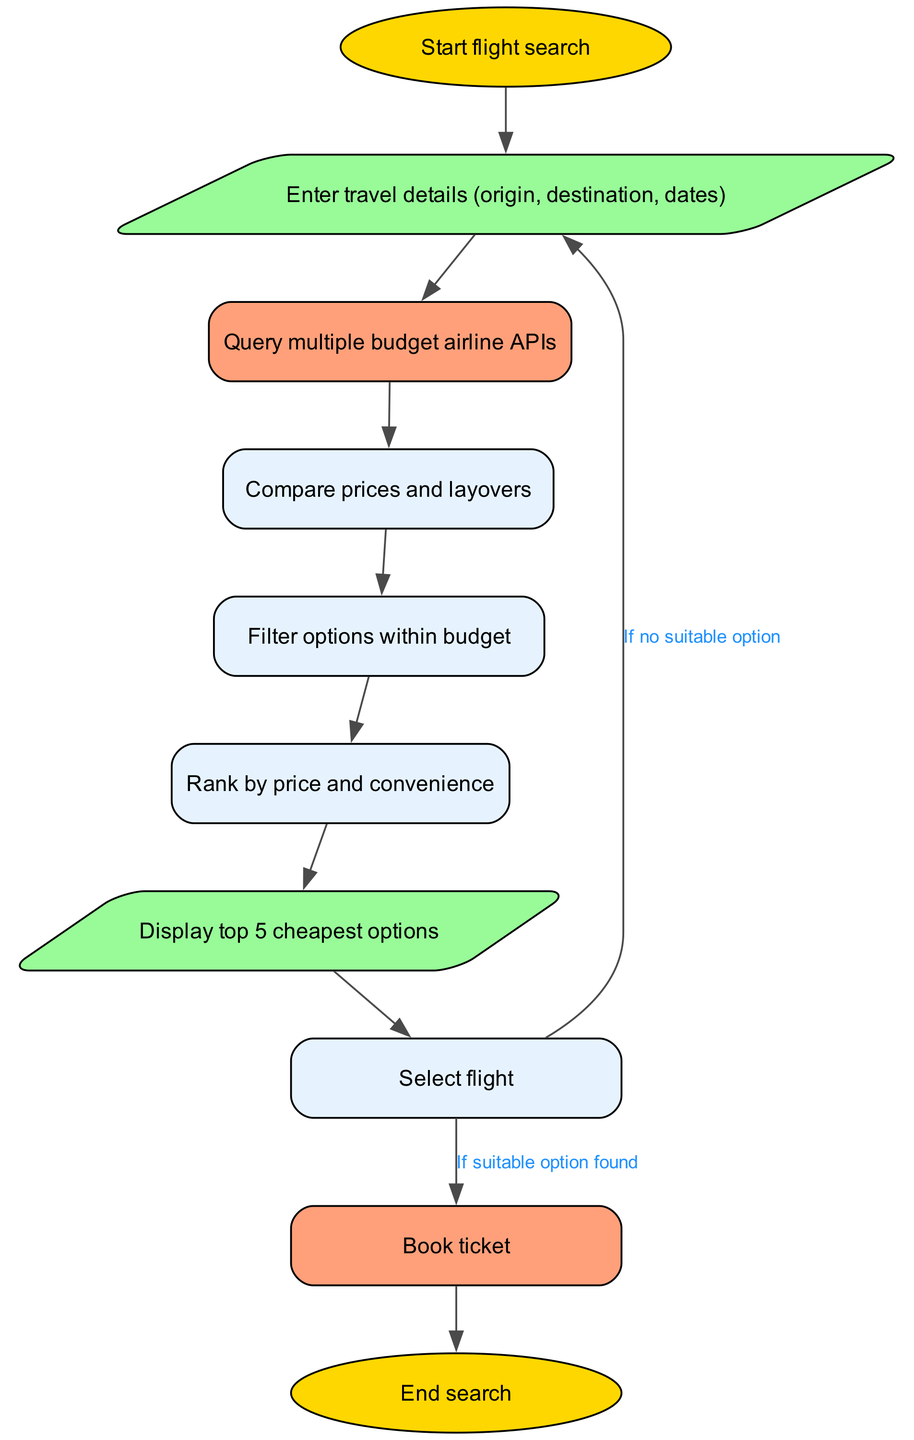What is the first step in the flight booking algorithm? The first step in the algorithm is the "Start flight search" node, which initiates the process. This node has a single outgoing edge that leads to the next node, where travel details are entered.
Answer: Start flight search How many nodes are there in the flowchart? By counting all the individual nodes represented in the diagram, we have a total of 10 nodes, starting from "Start flight search" to "End search".
Answer: 10 What is the purpose of the "Compare prices and layovers" node? This node serves to evaluate the options retrieved from the API, allowing the program to assess different flights based on their respective prices and layover times, helping users make informed choices.
Answer: Compare prices and layovers What happens if no suitable flight option is found? If no suitable option is identified after the selection, the algorithm loops back to the "Enter travel details" node, allowing the user to refine their input and search again.
Answer: Enter travel details What is the last step before completing the flight booking? The last step before finishing the process is the "Book ticket" node, which signifies that the chosen flight is finalized for purchase.
Answer: Book ticket What type of node is "Display top 5 cheapest options"? This node is a parallelogram, which typically represents input/output operations within flowcharts, indicating that it will show the user the best available options.
Answer: Parallelogram How many edges are there in the diagram? By counting the connections between nodes represented as edges, we find a total of 9 edges, indicating the flow of actions and decisions in the process.
Answer: 9 What does the "Rank by price and convenience" node do? This node prioritizes the options based on their cost-effectiveness and convenience factors, allowing users to select flights that best fit their needs.
Answer: Rank by price and convenience What node directly follows the "Filter options within budget" node? The node that follows "Filter options within budget" is "Rank by price and convenience," indicating the next logical step in the flow after filtering.
Answer: Rank by price and convenience 